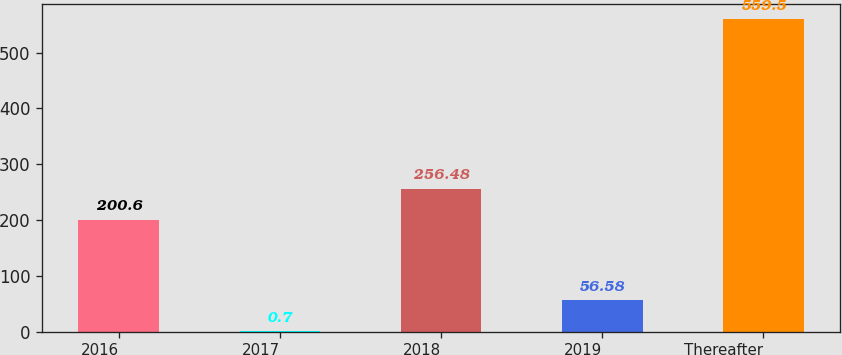Convert chart to OTSL. <chart><loc_0><loc_0><loc_500><loc_500><bar_chart><fcel>2016<fcel>2017<fcel>2018<fcel>2019<fcel>Thereafter<nl><fcel>200.6<fcel>0.7<fcel>256.48<fcel>56.58<fcel>559.5<nl></chart> 